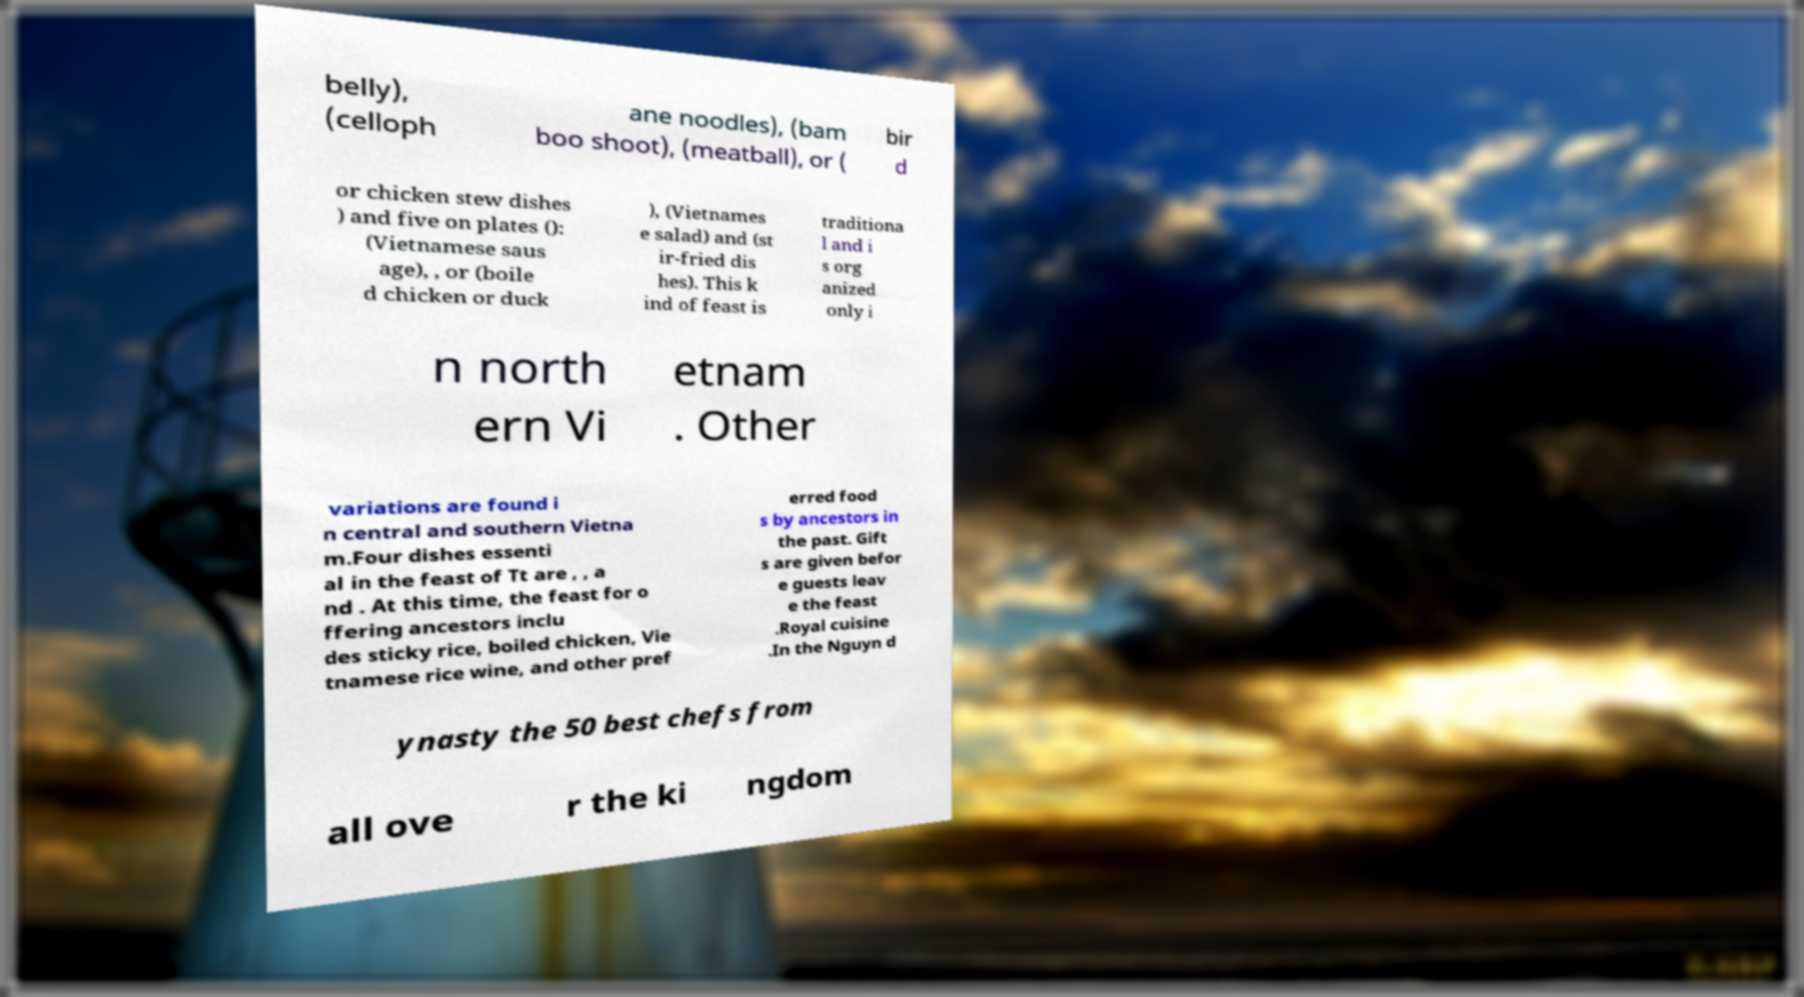Could you extract and type out the text from this image? belly), (celloph ane noodles), (bam boo shoot), (meatball), or ( bir d or chicken stew dishes ) and five on plates (): (Vietnamese saus age), , or (boile d chicken or duck ), (Vietnames e salad) and (st ir-fried dis hes). This k ind of feast is traditiona l and i s org anized only i n north ern Vi etnam . Other variations are found i n central and southern Vietna m.Four dishes essenti al in the feast of Tt are , , a nd . At this time, the feast for o ffering ancestors inclu des sticky rice, boiled chicken, Vie tnamese rice wine, and other pref erred food s by ancestors in the past. Gift s are given befor e guests leav e the feast .Royal cuisine .In the Nguyn d ynasty the 50 best chefs from all ove r the ki ngdom 